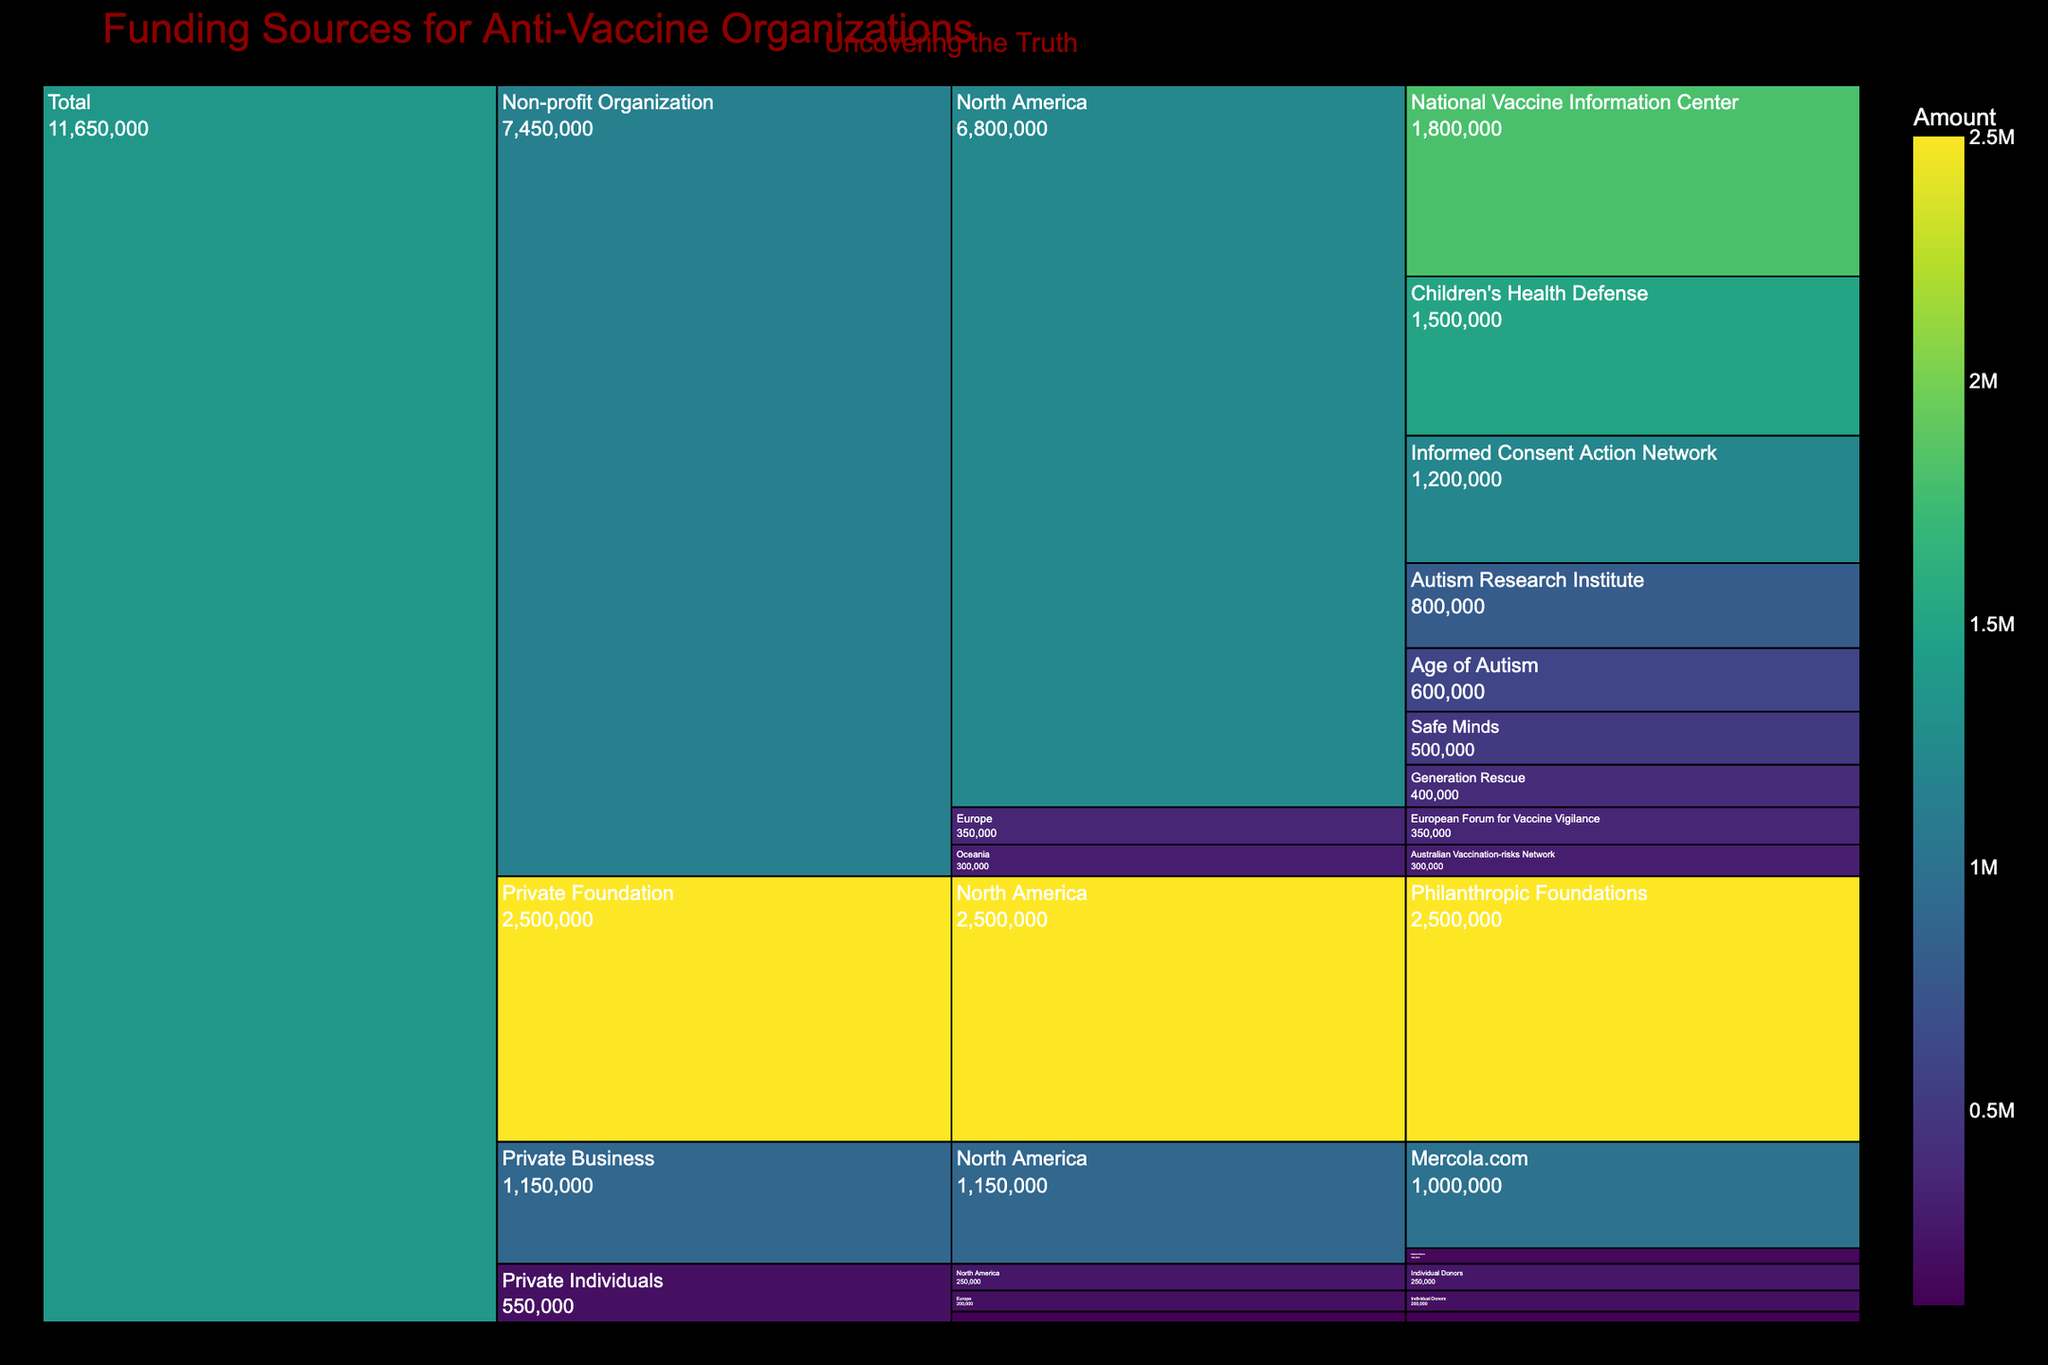Are all geographical regions equally represented in the funding data? Refer to the figure and observe the presence and size of sections representing different geographical regions. Notice the predominance of North America, while Europe, Oceania, and Asia have significantly smaller portions, indicating unequal representation.
Answer: No What is the total funding amount provided by Non-profit Organizations in North America? Identify all Non-profit Organizations within North America, sum up their individual funding amounts: National Vaccine Information Center ($1,800,000), Children's Health Defense ($1,500,000), Informed Consent Action Network ($1,200,000), Autism Research Institute ($800,000), Age of Autism ($600,000), Safe Minds ($500,000), Generation Rescue ($400,000). Sum is $1,800,000 + $1,500,000 + $1,200,000 + $800,000 + $600,000 + $500,000 + $400,000 = $6,800,000.
Answer: $6,800,000 Which funding source contributes the largest amount? Locate the sections with the highest value labels. The largest amount is under Philanthropic Foundations: $2,500,000.
Answer: Philanthropic Foundations How does the funding from Private Businesses in North America compare to that from Private Foundations? Find the sum of the funding from Private Businesses (Mercola.com: $1,000,000; Natural News: $150,000) and Private Foundations (Philanthropic Foundations: $2,500,000). Now compare $1,000,000 + $150,000 = $1,150,000 with $2,500,000.
Answer: Private Foundations contribute more What is the smallest funding amount from a Non-profit Organization in North America? Review the Non-profit Organization sections within North America and identify the smallest value. Generation Rescue is the smallest at $400,000.
Answer: $400,000 How many Non-profit Organizations from North America are listed? Count the segments under the Non-profit Organizations category specific to North America. Name the organizations: National Vaccine Information Center, Children's Health Defense, Informed Consent Action Network, Autism Research Institute, Age of Autism, Safe Minds, Generation Rescue. Total is 7.
Answer: 7 Which geographical region has the least funding from Private Individuals? Compare the sections representing Private Individuals across different regions. The smallest amount is under Asia: $100,000.
Answer: Asia What percentage of the total funding does the European Forum for Vaccine Vigilance contribute? Calculate the total funding by summing up all the amounts. Next, divide the European Forum for Vaccine Vigilance's amount ($350,000) by this total and multiply by 100. Total funding is $11,750,000. Percentage is ($350,000 / $11,750,000) * 100 ≈ 2.98%.
Answer: 2.98% What are the combined contributions of Individual Donors from all regions? Add up the amounts from Individual Donors across North America ($250,000), Europe ($200,000), and Asia ($100,000). Total: $250,000 + $200,000 + $100,000 = $550,000.
Answer: $550,000 